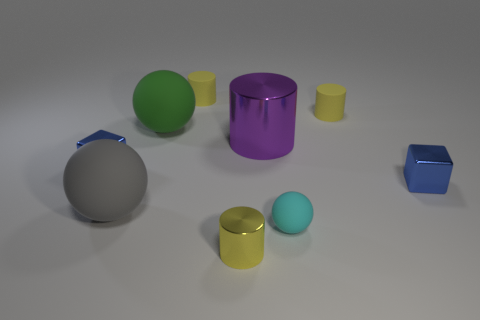Are there more small metallic objects that are behind the small cyan ball than red metal cubes?
Your answer should be very brief. Yes. There is a cyan thing; how many tiny blue metallic cubes are on the left side of it?
Your answer should be very brief. 1. There is a small shiny thing that is left of the large ball behind the large gray sphere; is there a small blue metal object on the right side of it?
Offer a terse response. Yes. Do the gray thing and the green object have the same size?
Keep it short and to the point. Yes. Is the number of green things to the right of the cyan matte thing the same as the number of purple shiny cylinders that are behind the green sphere?
Ensure brevity in your answer.  Yes. The thing in front of the small cyan sphere has what shape?
Provide a succinct answer. Cylinder. There is a green object that is the same size as the gray thing; what is its shape?
Keep it short and to the point. Sphere. There is a cylinder in front of the small blue metal block right of the small yellow matte cylinder on the left side of the purple object; what color is it?
Offer a very short reply. Yellow. Does the green thing have the same shape as the cyan rubber thing?
Keep it short and to the point. Yes. Are there the same number of large gray matte objects in front of the yellow metal object and small yellow metal objects?
Your answer should be compact. No. 